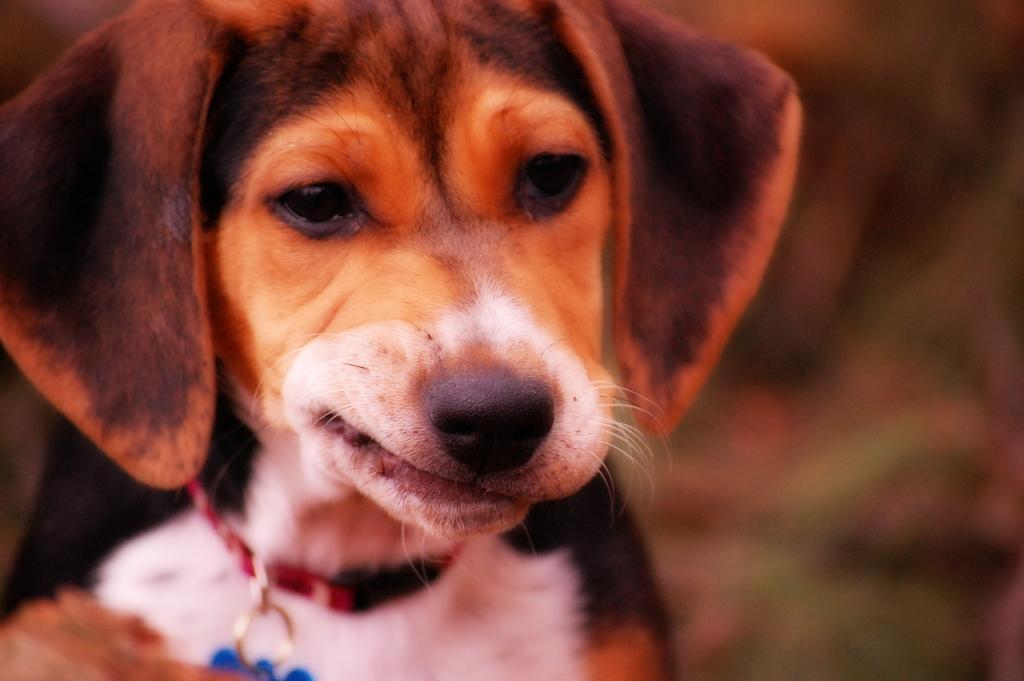Can you describe this image briefly? In this image, we can see a dog wearing a belt with blue locket. Background there is a blur view. 